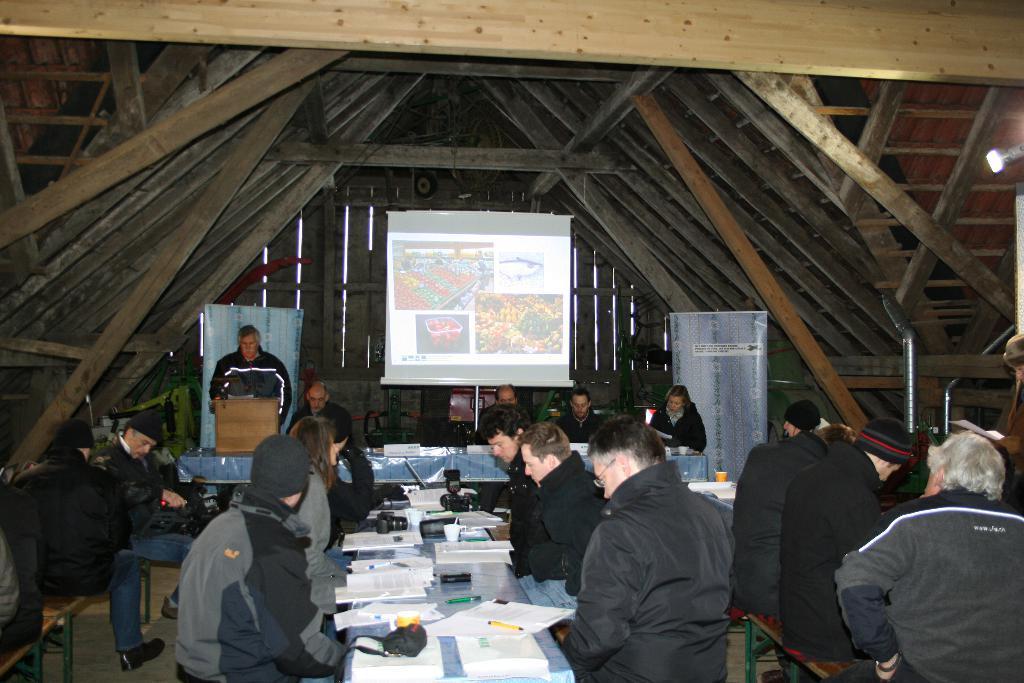Describe this image in one or two sentences. This image is taken under a wooden shed, where we can see, persons sitting on the benches or tables on which papers, cameras, markers, a cup are placed. In the background, there are persons sitting near a table and a man standing, two banners and a screen. 